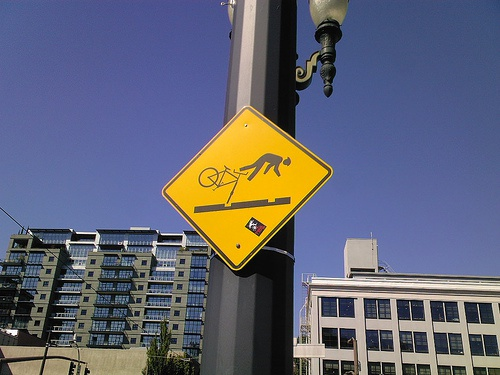Describe the objects in this image and their specific colors. I can see traffic light in black and blue tones and traffic light in blue, black, tan, gray, and darkgreen tones in this image. 